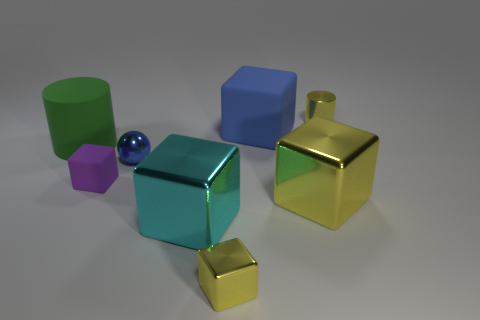Subtract all green balls. How many yellow cubes are left? 2 Subtract all blue cubes. How many cubes are left? 4 Subtract all big rubber cubes. How many cubes are left? 4 Add 1 green shiny spheres. How many objects exist? 9 Subtract all purple blocks. Subtract all purple cylinders. How many blocks are left? 4 Subtract all cylinders. How many objects are left? 6 Add 1 blue metallic things. How many blue metallic things are left? 2 Add 2 big brown matte blocks. How many big brown matte blocks exist? 2 Subtract 0 brown spheres. How many objects are left? 8 Subtract all big things. Subtract all tiny blue metal balls. How many objects are left? 3 